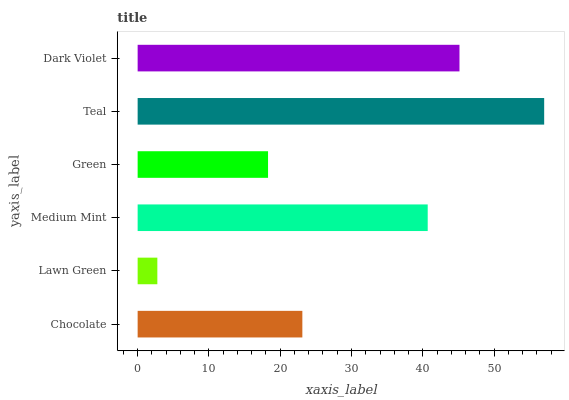Is Lawn Green the minimum?
Answer yes or no. Yes. Is Teal the maximum?
Answer yes or no. Yes. Is Medium Mint the minimum?
Answer yes or no. No. Is Medium Mint the maximum?
Answer yes or no. No. Is Medium Mint greater than Lawn Green?
Answer yes or no. Yes. Is Lawn Green less than Medium Mint?
Answer yes or no. Yes. Is Lawn Green greater than Medium Mint?
Answer yes or no. No. Is Medium Mint less than Lawn Green?
Answer yes or no. No. Is Medium Mint the high median?
Answer yes or no. Yes. Is Chocolate the low median?
Answer yes or no. Yes. Is Chocolate the high median?
Answer yes or no. No. Is Medium Mint the low median?
Answer yes or no. No. 